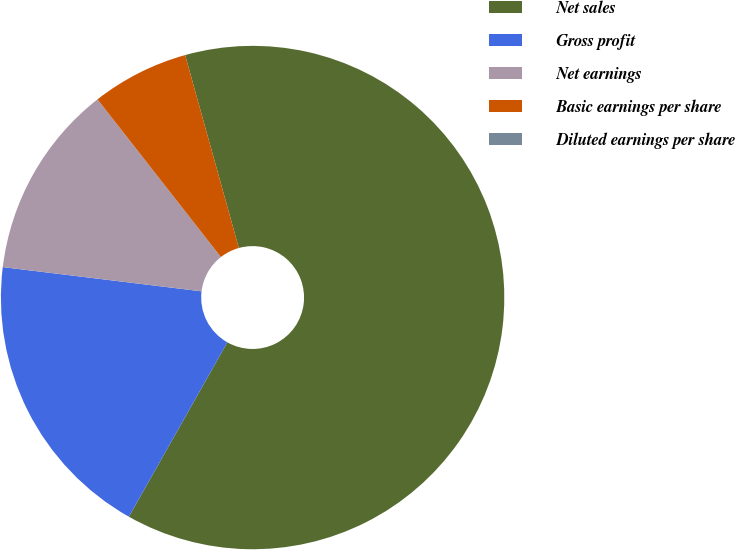Convert chart. <chart><loc_0><loc_0><loc_500><loc_500><pie_chart><fcel>Net sales<fcel>Gross profit<fcel>Net earnings<fcel>Basic earnings per share<fcel>Diluted earnings per share<nl><fcel>62.5%<fcel>18.75%<fcel>12.5%<fcel>6.25%<fcel>0.0%<nl></chart> 